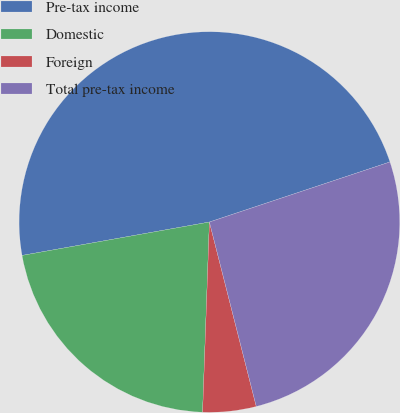<chart> <loc_0><loc_0><loc_500><loc_500><pie_chart><fcel>Pre-tax income<fcel>Domestic<fcel>Foreign<fcel>Total pre-tax income<nl><fcel>47.69%<fcel>21.62%<fcel>4.53%<fcel>26.15%<nl></chart> 